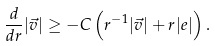<formula> <loc_0><loc_0><loc_500><loc_500>\frac { d } { d r } | \vec { v } | \geq - C \left ( r ^ { - 1 } | \vec { v } | + r | e | \right ) .</formula> 